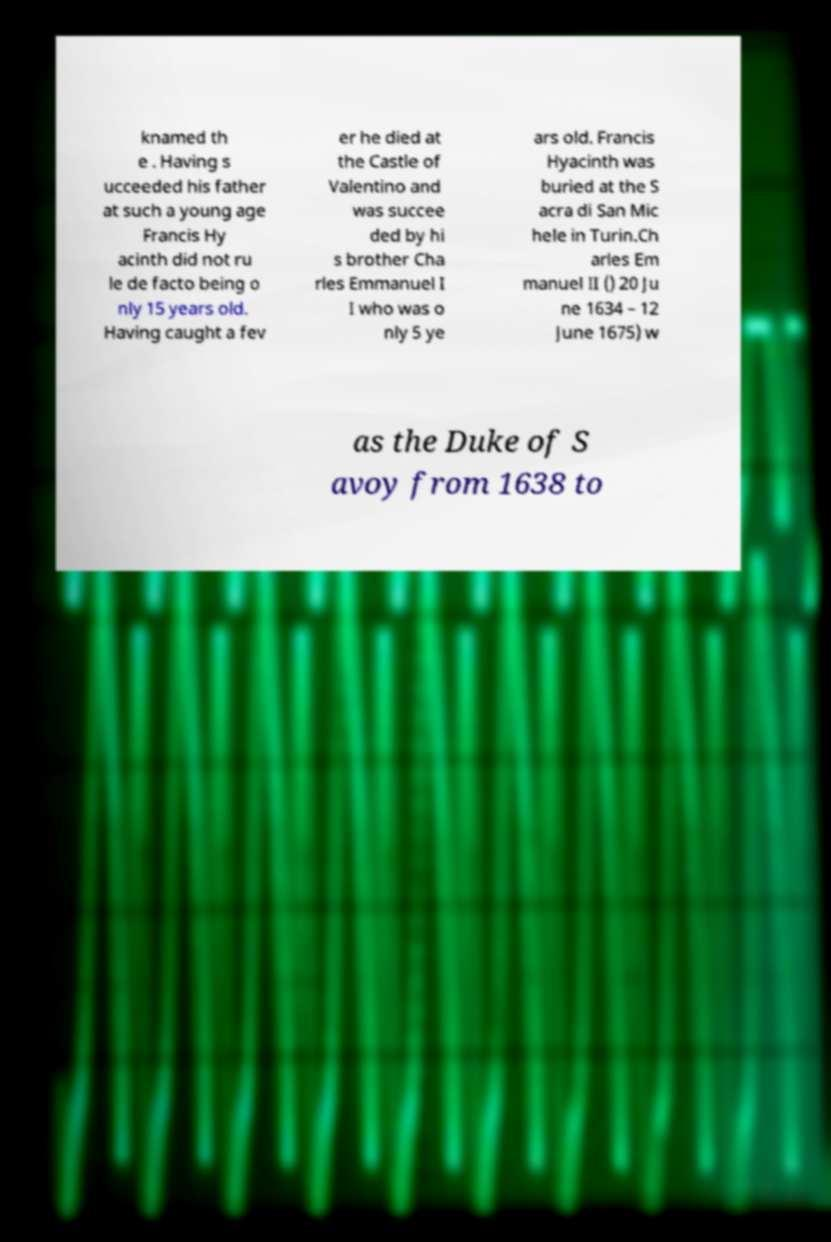Could you extract and type out the text from this image? knamed th e . Having s ucceeded his father at such a young age Francis Hy acinth did not ru le de facto being o nly 15 years old. Having caught a fev er he died at the Castle of Valentino and was succee ded by hi s brother Cha rles Emmanuel I I who was o nly 5 ye ars old. Francis Hyacinth was buried at the S acra di San Mic hele in Turin.Ch arles Em manuel II () 20 Ju ne 1634 – 12 June 1675) w as the Duke of S avoy from 1638 to 